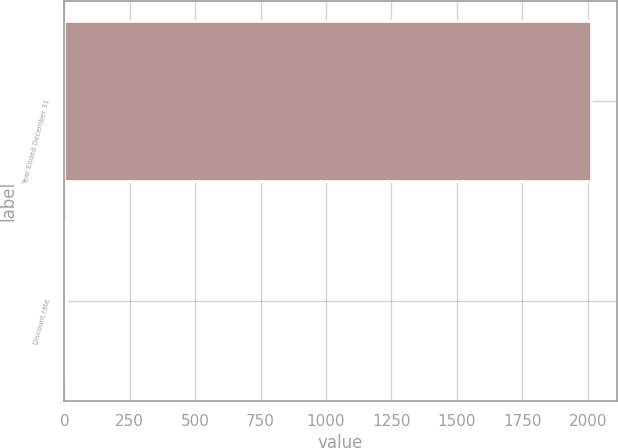Convert chart. <chart><loc_0><loc_0><loc_500><loc_500><bar_chart><fcel>Year Ended December 31<fcel>Discount rate<nl><fcel>2011<fcel>5<nl></chart> 